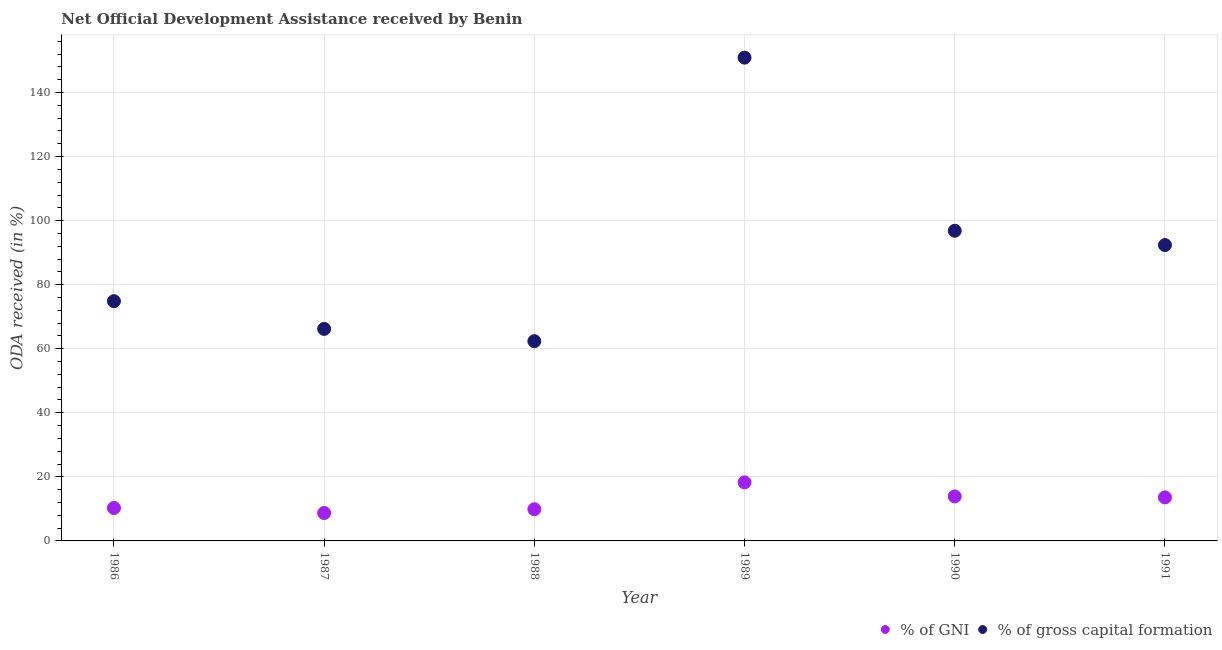What is the oda received as percentage of gross capital formation in 1990?
Ensure brevity in your answer.  96.84. Across all years, what is the maximum oda received as percentage of gni?
Make the answer very short. 18.3. Across all years, what is the minimum oda received as percentage of gross capital formation?
Give a very brief answer. 62.37. In which year was the oda received as percentage of gross capital formation maximum?
Your answer should be very brief. 1989. What is the total oda received as percentage of gross capital formation in the graph?
Provide a succinct answer. 543.53. What is the difference between the oda received as percentage of gross capital formation in 1987 and that in 1989?
Provide a succinct answer. -84.69. What is the difference between the oda received as percentage of gni in 1986 and the oda received as percentage of gross capital formation in 1991?
Offer a terse response. -82.09. What is the average oda received as percentage of gni per year?
Ensure brevity in your answer.  12.45. In the year 1986, what is the difference between the oda received as percentage of gni and oda received as percentage of gross capital formation?
Keep it short and to the point. -64.58. In how many years, is the oda received as percentage of gni greater than 140 %?
Your answer should be very brief. 0. What is the ratio of the oda received as percentage of gross capital formation in 1987 to that in 1989?
Your answer should be very brief. 0.44. Is the difference between the oda received as percentage of gross capital formation in 1987 and 1989 greater than the difference between the oda received as percentage of gni in 1987 and 1989?
Your answer should be very brief. No. What is the difference between the highest and the second highest oda received as percentage of gni?
Keep it short and to the point. 4.4. What is the difference between the highest and the lowest oda received as percentage of gni?
Provide a succinct answer. 9.58. In how many years, is the oda received as percentage of gni greater than the average oda received as percentage of gni taken over all years?
Your response must be concise. 3. Is the sum of the oda received as percentage of gni in 1986 and 1990 greater than the maximum oda received as percentage of gross capital formation across all years?
Make the answer very short. No. Does the oda received as percentage of gross capital formation monotonically increase over the years?
Make the answer very short. No. Is the oda received as percentage of gross capital formation strictly greater than the oda received as percentage of gni over the years?
Your response must be concise. Yes. Is the oda received as percentage of gni strictly less than the oda received as percentage of gross capital formation over the years?
Ensure brevity in your answer.  Yes. How many years are there in the graph?
Give a very brief answer. 6. What is the difference between two consecutive major ticks on the Y-axis?
Ensure brevity in your answer.  20. Are the values on the major ticks of Y-axis written in scientific E-notation?
Make the answer very short. No. Does the graph contain any zero values?
Your answer should be compact. No. Does the graph contain grids?
Offer a terse response. Yes. Where does the legend appear in the graph?
Your answer should be very brief. Bottom right. How are the legend labels stacked?
Ensure brevity in your answer.  Horizontal. What is the title of the graph?
Make the answer very short. Net Official Development Assistance received by Benin. Does "Quality of trade" appear as one of the legend labels in the graph?
Your answer should be very brief. No. What is the label or title of the Y-axis?
Provide a succinct answer. ODA received (in %). What is the ODA received (in %) of % of GNI in 1986?
Make the answer very short. 10.28. What is the ODA received (in %) in % of gross capital formation in 1986?
Keep it short and to the point. 74.86. What is the ODA received (in %) in % of GNI in 1987?
Your response must be concise. 8.72. What is the ODA received (in %) of % of gross capital formation in 1987?
Your response must be concise. 66.2. What is the ODA received (in %) in % of GNI in 1988?
Your answer should be very brief. 9.9. What is the ODA received (in %) of % of gross capital formation in 1988?
Make the answer very short. 62.37. What is the ODA received (in %) of % of GNI in 1989?
Make the answer very short. 18.3. What is the ODA received (in %) of % of gross capital formation in 1989?
Make the answer very short. 150.89. What is the ODA received (in %) of % of GNI in 1990?
Your answer should be very brief. 13.89. What is the ODA received (in %) of % of gross capital formation in 1990?
Make the answer very short. 96.84. What is the ODA received (in %) of % of GNI in 1991?
Give a very brief answer. 13.58. What is the ODA received (in %) of % of gross capital formation in 1991?
Keep it short and to the point. 92.37. Across all years, what is the maximum ODA received (in %) of % of GNI?
Offer a very short reply. 18.3. Across all years, what is the maximum ODA received (in %) in % of gross capital formation?
Your answer should be very brief. 150.89. Across all years, what is the minimum ODA received (in %) of % of GNI?
Ensure brevity in your answer.  8.72. Across all years, what is the minimum ODA received (in %) of % of gross capital formation?
Provide a succinct answer. 62.37. What is the total ODA received (in %) in % of GNI in the graph?
Make the answer very short. 74.67. What is the total ODA received (in %) in % of gross capital formation in the graph?
Your answer should be compact. 543.53. What is the difference between the ODA received (in %) in % of GNI in 1986 and that in 1987?
Offer a terse response. 1.56. What is the difference between the ODA received (in %) in % of gross capital formation in 1986 and that in 1987?
Your answer should be compact. 8.66. What is the difference between the ODA received (in %) of % of GNI in 1986 and that in 1988?
Keep it short and to the point. 0.38. What is the difference between the ODA received (in %) of % of gross capital formation in 1986 and that in 1988?
Give a very brief answer. 12.49. What is the difference between the ODA received (in %) of % of GNI in 1986 and that in 1989?
Your answer should be very brief. -8.02. What is the difference between the ODA received (in %) in % of gross capital formation in 1986 and that in 1989?
Give a very brief answer. -76.03. What is the difference between the ODA received (in %) of % of GNI in 1986 and that in 1990?
Provide a succinct answer. -3.61. What is the difference between the ODA received (in %) in % of gross capital formation in 1986 and that in 1990?
Offer a very short reply. -21.98. What is the difference between the ODA received (in %) of % of GNI in 1986 and that in 1991?
Your answer should be compact. -3.31. What is the difference between the ODA received (in %) in % of gross capital formation in 1986 and that in 1991?
Make the answer very short. -17.51. What is the difference between the ODA received (in %) in % of GNI in 1987 and that in 1988?
Keep it short and to the point. -1.18. What is the difference between the ODA received (in %) of % of gross capital formation in 1987 and that in 1988?
Offer a terse response. 3.83. What is the difference between the ODA received (in %) of % of GNI in 1987 and that in 1989?
Your answer should be compact. -9.58. What is the difference between the ODA received (in %) of % of gross capital formation in 1987 and that in 1989?
Make the answer very short. -84.69. What is the difference between the ODA received (in %) in % of GNI in 1987 and that in 1990?
Keep it short and to the point. -5.18. What is the difference between the ODA received (in %) of % of gross capital formation in 1987 and that in 1990?
Give a very brief answer. -30.65. What is the difference between the ODA received (in %) in % of GNI in 1987 and that in 1991?
Make the answer very short. -4.87. What is the difference between the ODA received (in %) of % of gross capital formation in 1987 and that in 1991?
Your answer should be very brief. -26.17. What is the difference between the ODA received (in %) of % of GNI in 1988 and that in 1989?
Provide a succinct answer. -8.39. What is the difference between the ODA received (in %) of % of gross capital formation in 1988 and that in 1989?
Offer a very short reply. -88.52. What is the difference between the ODA received (in %) in % of GNI in 1988 and that in 1990?
Provide a succinct answer. -3.99. What is the difference between the ODA received (in %) of % of gross capital formation in 1988 and that in 1990?
Your response must be concise. -34.48. What is the difference between the ODA received (in %) of % of GNI in 1988 and that in 1991?
Offer a terse response. -3.68. What is the difference between the ODA received (in %) of % of gross capital formation in 1988 and that in 1991?
Offer a very short reply. -30.01. What is the difference between the ODA received (in %) in % of GNI in 1989 and that in 1990?
Provide a short and direct response. 4.4. What is the difference between the ODA received (in %) of % of gross capital formation in 1989 and that in 1990?
Keep it short and to the point. 54.04. What is the difference between the ODA received (in %) of % of GNI in 1989 and that in 1991?
Ensure brevity in your answer.  4.71. What is the difference between the ODA received (in %) of % of gross capital formation in 1989 and that in 1991?
Ensure brevity in your answer.  58.52. What is the difference between the ODA received (in %) of % of GNI in 1990 and that in 1991?
Provide a short and direct response. 0.31. What is the difference between the ODA received (in %) of % of gross capital formation in 1990 and that in 1991?
Your response must be concise. 4.47. What is the difference between the ODA received (in %) of % of GNI in 1986 and the ODA received (in %) of % of gross capital formation in 1987?
Offer a terse response. -55.92. What is the difference between the ODA received (in %) of % of GNI in 1986 and the ODA received (in %) of % of gross capital formation in 1988?
Keep it short and to the point. -52.09. What is the difference between the ODA received (in %) in % of GNI in 1986 and the ODA received (in %) in % of gross capital formation in 1989?
Your response must be concise. -140.61. What is the difference between the ODA received (in %) of % of GNI in 1986 and the ODA received (in %) of % of gross capital formation in 1990?
Offer a terse response. -86.56. What is the difference between the ODA received (in %) of % of GNI in 1986 and the ODA received (in %) of % of gross capital formation in 1991?
Give a very brief answer. -82.09. What is the difference between the ODA received (in %) in % of GNI in 1987 and the ODA received (in %) in % of gross capital formation in 1988?
Provide a short and direct response. -53.65. What is the difference between the ODA received (in %) of % of GNI in 1987 and the ODA received (in %) of % of gross capital formation in 1989?
Your answer should be very brief. -142.17. What is the difference between the ODA received (in %) of % of GNI in 1987 and the ODA received (in %) of % of gross capital formation in 1990?
Your response must be concise. -88.13. What is the difference between the ODA received (in %) in % of GNI in 1987 and the ODA received (in %) in % of gross capital formation in 1991?
Offer a terse response. -83.66. What is the difference between the ODA received (in %) in % of GNI in 1988 and the ODA received (in %) in % of gross capital formation in 1989?
Your answer should be very brief. -140.99. What is the difference between the ODA received (in %) of % of GNI in 1988 and the ODA received (in %) of % of gross capital formation in 1990?
Offer a very short reply. -86.94. What is the difference between the ODA received (in %) in % of GNI in 1988 and the ODA received (in %) in % of gross capital formation in 1991?
Your answer should be compact. -82.47. What is the difference between the ODA received (in %) in % of GNI in 1989 and the ODA received (in %) in % of gross capital formation in 1990?
Your answer should be very brief. -78.55. What is the difference between the ODA received (in %) of % of GNI in 1989 and the ODA received (in %) of % of gross capital formation in 1991?
Provide a short and direct response. -74.08. What is the difference between the ODA received (in %) in % of GNI in 1990 and the ODA received (in %) in % of gross capital formation in 1991?
Provide a short and direct response. -78.48. What is the average ODA received (in %) in % of GNI per year?
Keep it short and to the point. 12.45. What is the average ODA received (in %) in % of gross capital formation per year?
Give a very brief answer. 90.59. In the year 1986, what is the difference between the ODA received (in %) of % of GNI and ODA received (in %) of % of gross capital formation?
Make the answer very short. -64.58. In the year 1987, what is the difference between the ODA received (in %) of % of GNI and ODA received (in %) of % of gross capital formation?
Keep it short and to the point. -57.48. In the year 1988, what is the difference between the ODA received (in %) in % of GNI and ODA received (in %) in % of gross capital formation?
Provide a succinct answer. -52.46. In the year 1989, what is the difference between the ODA received (in %) in % of GNI and ODA received (in %) in % of gross capital formation?
Make the answer very short. -132.59. In the year 1990, what is the difference between the ODA received (in %) in % of GNI and ODA received (in %) in % of gross capital formation?
Offer a terse response. -82.95. In the year 1991, what is the difference between the ODA received (in %) of % of GNI and ODA received (in %) of % of gross capital formation?
Give a very brief answer. -78.79. What is the ratio of the ODA received (in %) in % of GNI in 1986 to that in 1987?
Make the answer very short. 1.18. What is the ratio of the ODA received (in %) in % of gross capital formation in 1986 to that in 1987?
Provide a short and direct response. 1.13. What is the ratio of the ODA received (in %) of % of GNI in 1986 to that in 1988?
Your answer should be compact. 1.04. What is the ratio of the ODA received (in %) of % of gross capital formation in 1986 to that in 1988?
Ensure brevity in your answer.  1.2. What is the ratio of the ODA received (in %) in % of GNI in 1986 to that in 1989?
Ensure brevity in your answer.  0.56. What is the ratio of the ODA received (in %) in % of gross capital formation in 1986 to that in 1989?
Keep it short and to the point. 0.5. What is the ratio of the ODA received (in %) in % of GNI in 1986 to that in 1990?
Your answer should be very brief. 0.74. What is the ratio of the ODA received (in %) in % of gross capital formation in 1986 to that in 1990?
Give a very brief answer. 0.77. What is the ratio of the ODA received (in %) of % of GNI in 1986 to that in 1991?
Make the answer very short. 0.76. What is the ratio of the ODA received (in %) in % of gross capital formation in 1986 to that in 1991?
Offer a very short reply. 0.81. What is the ratio of the ODA received (in %) in % of GNI in 1987 to that in 1988?
Your answer should be compact. 0.88. What is the ratio of the ODA received (in %) of % of gross capital formation in 1987 to that in 1988?
Provide a short and direct response. 1.06. What is the ratio of the ODA received (in %) of % of GNI in 1987 to that in 1989?
Provide a short and direct response. 0.48. What is the ratio of the ODA received (in %) of % of gross capital formation in 1987 to that in 1989?
Give a very brief answer. 0.44. What is the ratio of the ODA received (in %) of % of GNI in 1987 to that in 1990?
Keep it short and to the point. 0.63. What is the ratio of the ODA received (in %) of % of gross capital formation in 1987 to that in 1990?
Keep it short and to the point. 0.68. What is the ratio of the ODA received (in %) in % of GNI in 1987 to that in 1991?
Your answer should be very brief. 0.64. What is the ratio of the ODA received (in %) in % of gross capital formation in 1987 to that in 1991?
Provide a short and direct response. 0.72. What is the ratio of the ODA received (in %) of % of GNI in 1988 to that in 1989?
Offer a terse response. 0.54. What is the ratio of the ODA received (in %) in % of gross capital formation in 1988 to that in 1989?
Keep it short and to the point. 0.41. What is the ratio of the ODA received (in %) in % of GNI in 1988 to that in 1990?
Provide a succinct answer. 0.71. What is the ratio of the ODA received (in %) of % of gross capital formation in 1988 to that in 1990?
Ensure brevity in your answer.  0.64. What is the ratio of the ODA received (in %) in % of GNI in 1988 to that in 1991?
Make the answer very short. 0.73. What is the ratio of the ODA received (in %) of % of gross capital formation in 1988 to that in 1991?
Make the answer very short. 0.68. What is the ratio of the ODA received (in %) in % of GNI in 1989 to that in 1990?
Ensure brevity in your answer.  1.32. What is the ratio of the ODA received (in %) in % of gross capital formation in 1989 to that in 1990?
Your answer should be compact. 1.56. What is the ratio of the ODA received (in %) of % of GNI in 1989 to that in 1991?
Your response must be concise. 1.35. What is the ratio of the ODA received (in %) of % of gross capital formation in 1989 to that in 1991?
Your answer should be very brief. 1.63. What is the ratio of the ODA received (in %) of % of GNI in 1990 to that in 1991?
Keep it short and to the point. 1.02. What is the ratio of the ODA received (in %) in % of gross capital formation in 1990 to that in 1991?
Your answer should be very brief. 1.05. What is the difference between the highest and the second highest ODA received (in %) in % of GNI?
Offer a terse response. 4.4. What is the difference between the highest and the second highest ODA received (in %) of % of gross capital formation?
Offer a very short reply. 54.04. What is the difference between the highest and the lowest ODA received (in %) in % of GNI?
Give a very brief answer. 9.58. What is the difference between the highest and the lowest ODA received (in %) of % of gross capital formation?
Make the answer very short. 88.52. 